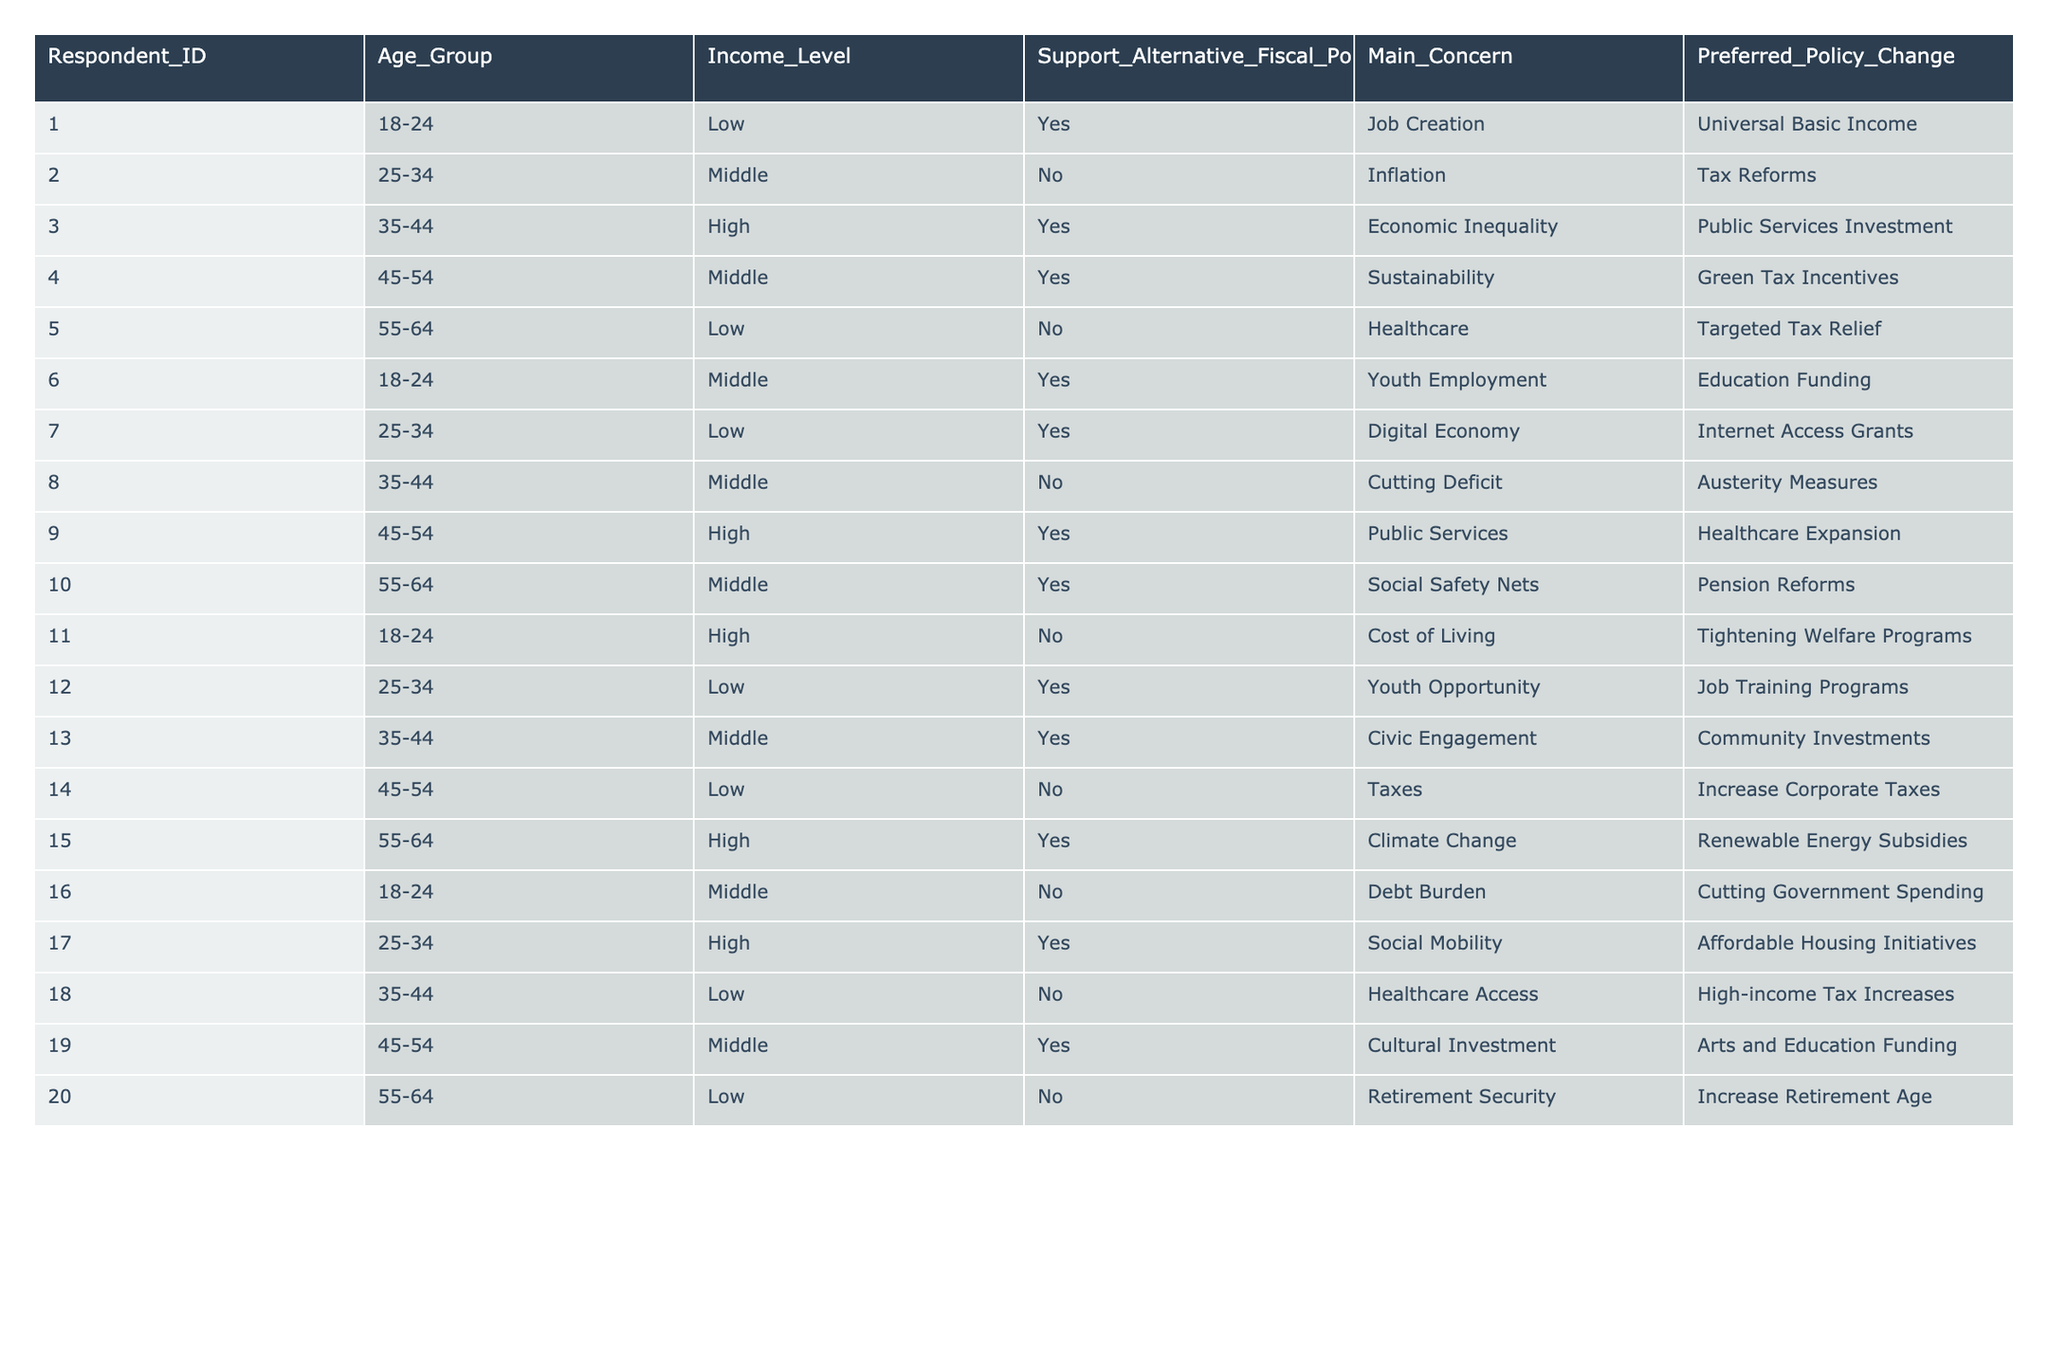What percentage of respondents support alternative fiscal policies? There are 12 respondents in total, and 8 of them support alternative fiscal policies. Therefore, the percentage is (8/12) * 100 = 66.67%.
Answer: 66.67% What is the main concern of the respondent who supports public services investment? The respondent who supports public services investment (ID 3) has the main concern of economic inequality.
Answer: Economic Inequality How many respondents from the age group 45-54 are against alternative fiscal policies? In the age group 45-54, there are 4 respondents. Out of them, 2 are against alternative fiscal policies (IDs 8 and 14).
Answer: 2 Is there any respondent who supports universal basic income? Yes, there is one respondent (ID 1) who supports universal basic income.
Answer: Yes How many respondents in the high-income level group support alternative fiscal policies? In the high-income level group, there are 5 respondents, and 3 of them support alternative fiscal policies (IDs 3, 9, and 15).
Answer: 3 What is the total number of concerns listed by respondents who support alternative fiscal policies? There are a total of 8 respondents who support alternative fiscal policies, and each of them has a unique main concern. Thus, the total number of concerns is 8.
Answer: 8 Among respondents with a low income, what is the preferred policy change for those who support alternative fiscal policies? Among the respondents with a low income who support alternative fiscal policies, the preferred policy changes are universal basic income (ID 1) and job training programs (ID 12).
Answer: Universal Basic Income and Job Training Programs Which age group has the highest representation among those against alternative fiscal policies? The age group 55-64 has the highest representation against alternative fiscal policies, with 3 respondents (IDs 5, 11, and 20).
Answer: 55-64 What is the average age of respondents who prefer tax reforms? The respondents who prefer tax reforms are from ages 25-34 and 55-64. The average age calculation is as follows: (29.5 for 25-34 and 59.5 for 55-64, averaged gives (29.5 + 59.5)/2 = 44.5).
Answer: 44.5 Are there any respondents who support both pension reforms and renewable energy subsidies? No, there are no respondents who support both pension reforms (ID 10) and renewable energy subsidies (ID 15) as they belong to different individuals.
Answer: No 